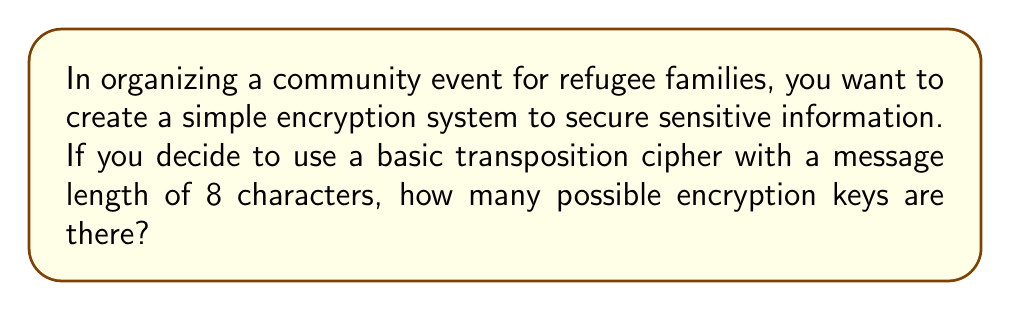Can you answer this question? Let's approach this step-by-step:

1) A basic transposition cipher rearranges the characters in a message according to a specific pattern.

2) For a message of length 8, we need to consider all possible ways to rearrange 8 characters.

3) This is a permutation problem. We're asking how many ways we can arrange 8 distinct objects.

4) The number of permutations of $n$ distinct objects is given by the factorial of $n$, denoted as $n!$.

5) In this case, $n = 8$, so we need to calculate $8!$.

6) $8! = 8 \times 7 \times 6 \times 5 \times 4 \times 3 \times 2 \times 1$

7) Let's calculate this:
   $$8! = 8 \times 7 \times 6 \times 5 \times 4 \times 3 \times 2 \times 1 = 40,320$$

Therefore, there are 40,320 possible encryption keys for this transposition cipher.
Answer: 40,320 